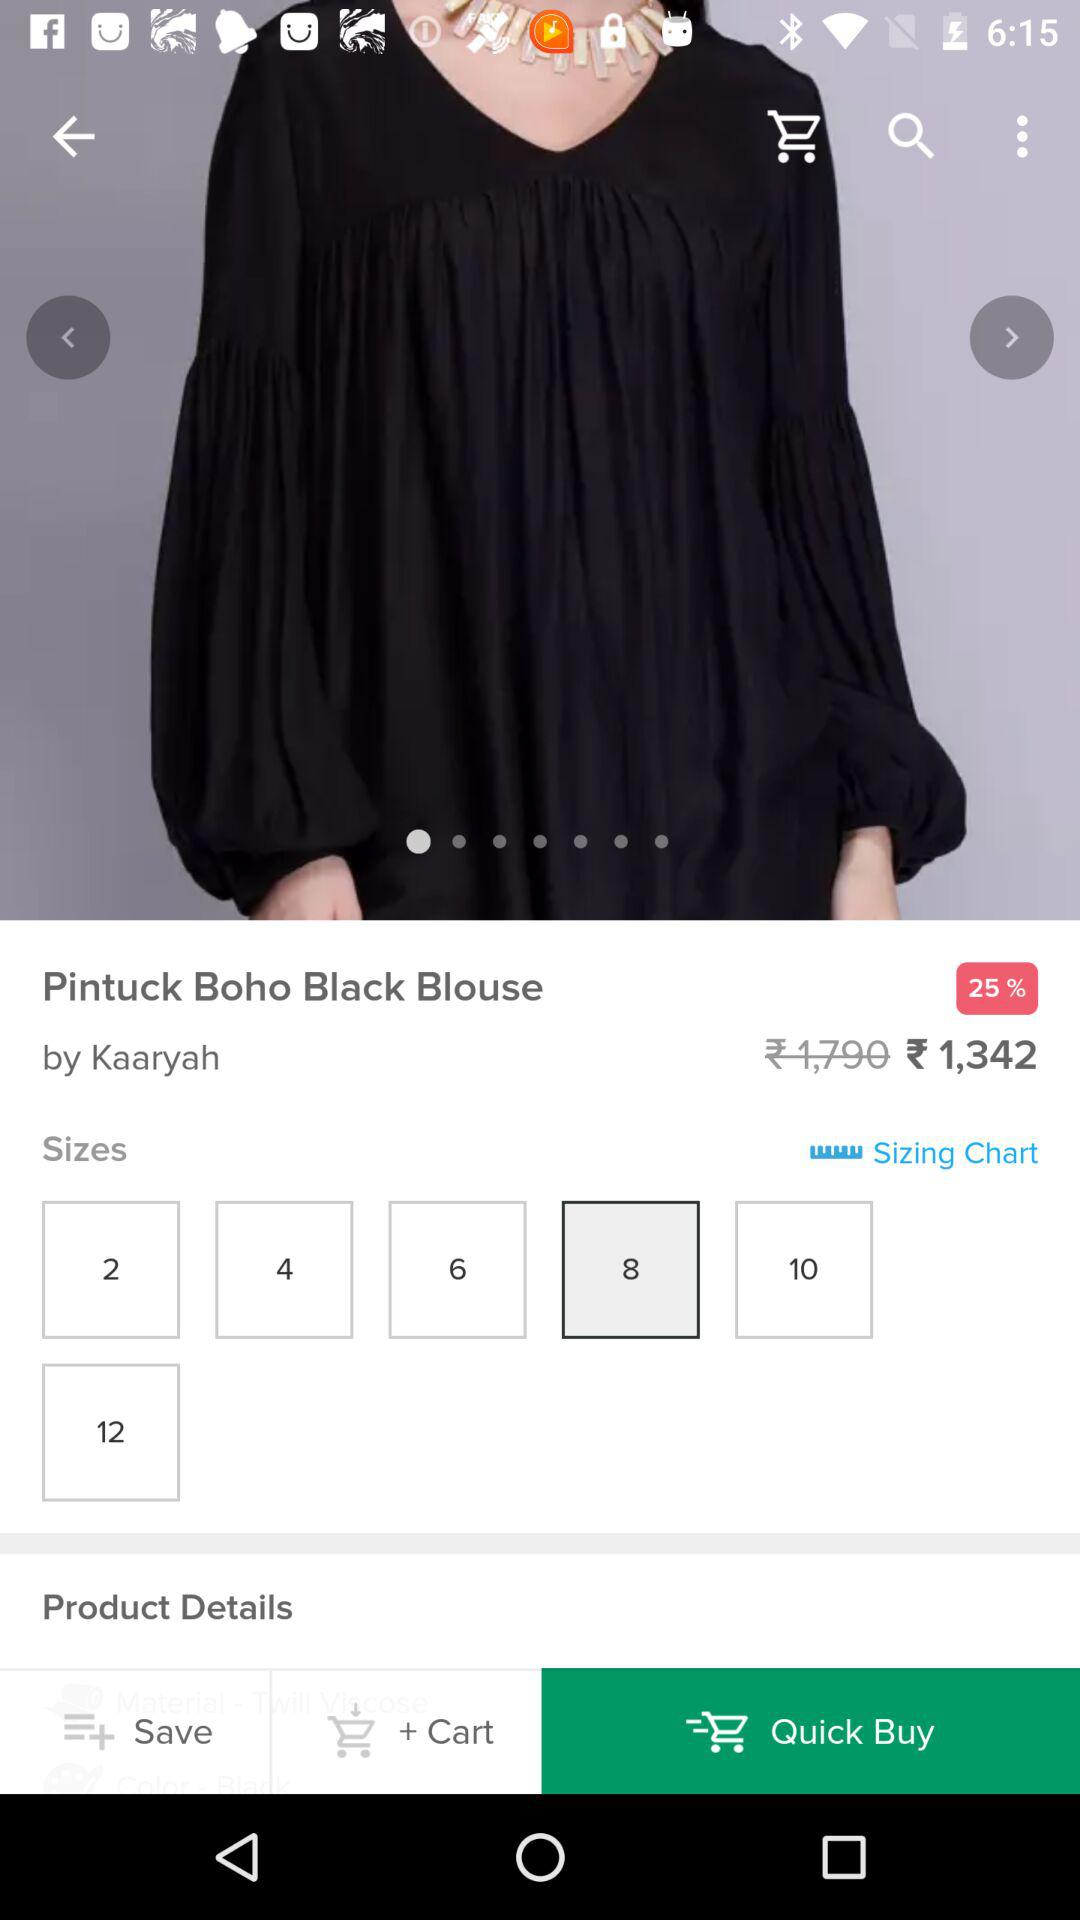What is the discounted price of the product? The discounted price of the product is ₹1,342. 